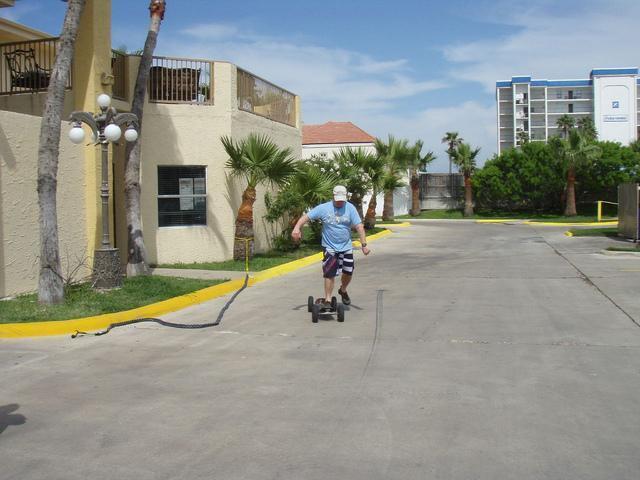What is unusual about the man's skateboard?
Indicate the correct choice and explain in the format: 'Answer: answer
Rationale: rationale.'
Options: Inline, primer color, miniature, big wheels. Answer: big wheels.
Rationale: You can see that the round rolling parts are very large relative to the size of the board. normally, skateboards have small ones. 